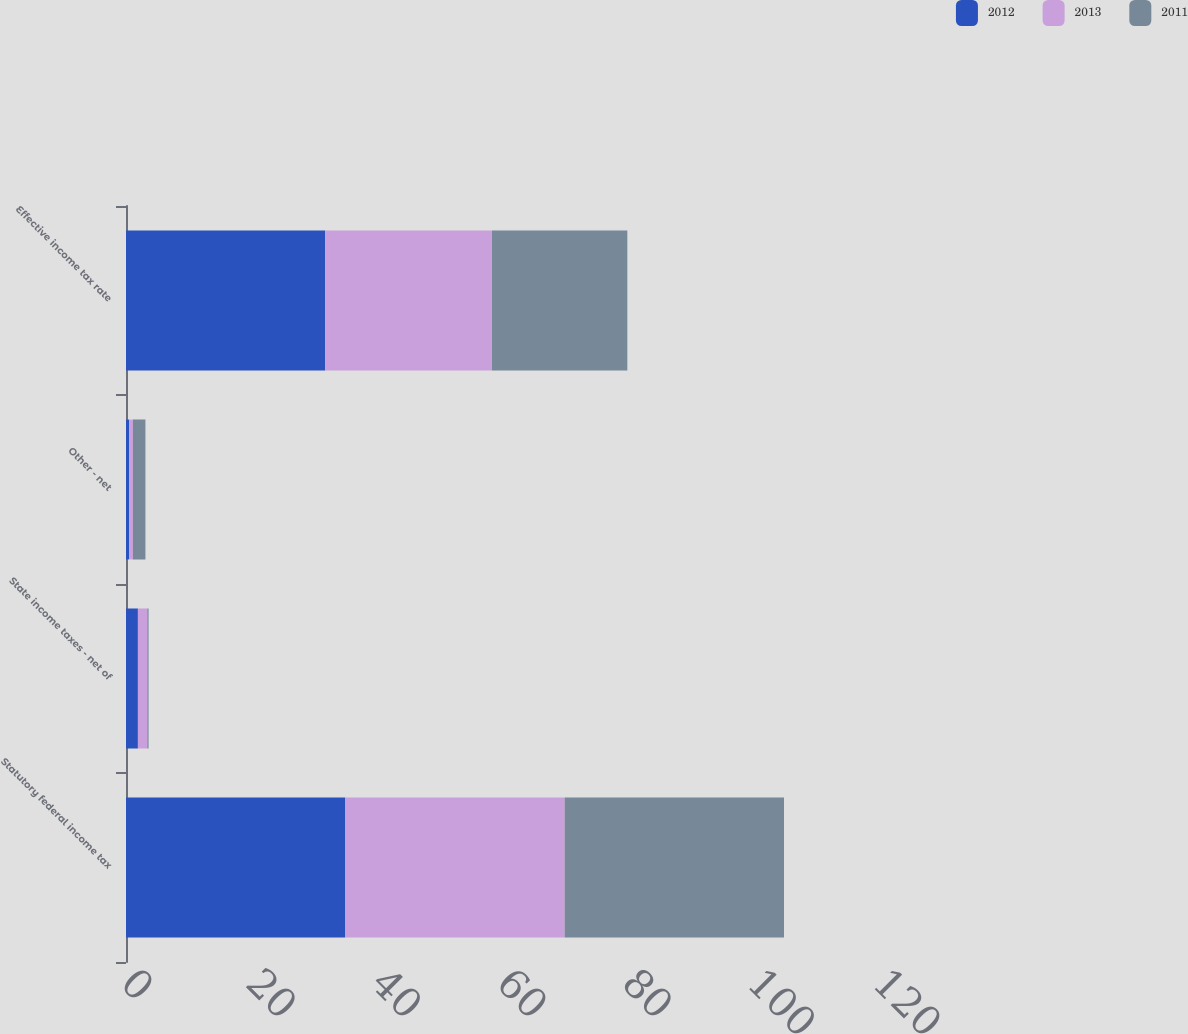Convert chart to OTSL. <chart><loc_0><loc_0><loc_500><loc_500><stacked_bar_chart><ecel><fcel>Statutory federal income tax<fcel>State income taxes - net of<fcel>Other - net<fcel>Effective income tax rate<nl><fcel>2012<fcel>35<fcel>1.9<fcel>0.5<fcel>31.8<nl><fcel>2013<fcel>35<fcel>1.5<fcel>0.6<fcel>26.6<nl><fcel>2011<fcel>35<fcel>0.2<fcel>2<fcel>21.6<nl></chart> 